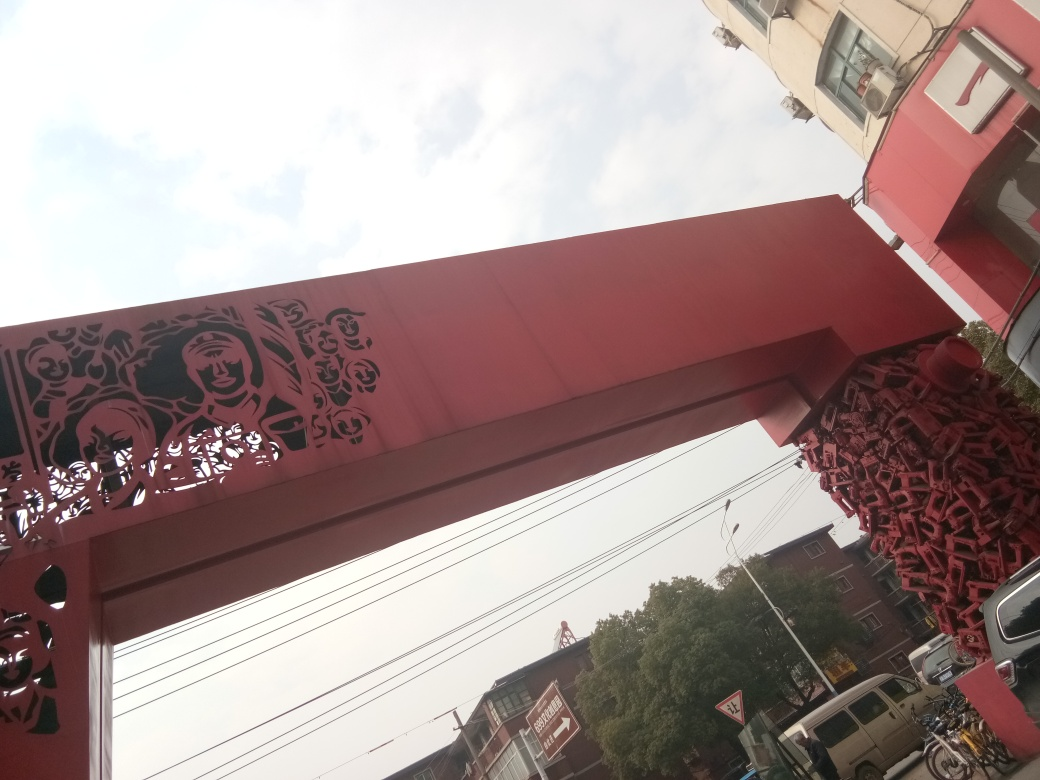What could be the cultural significance of this structure based on its design? Based on the design, the structure likely holds cultural significance, possibly representing traditional motifs or heritage figures. The artistry involved suggests that it may be an important landmark or monument within the local community, possibly serving as a gateway or marker for a culturally significant area or event. 